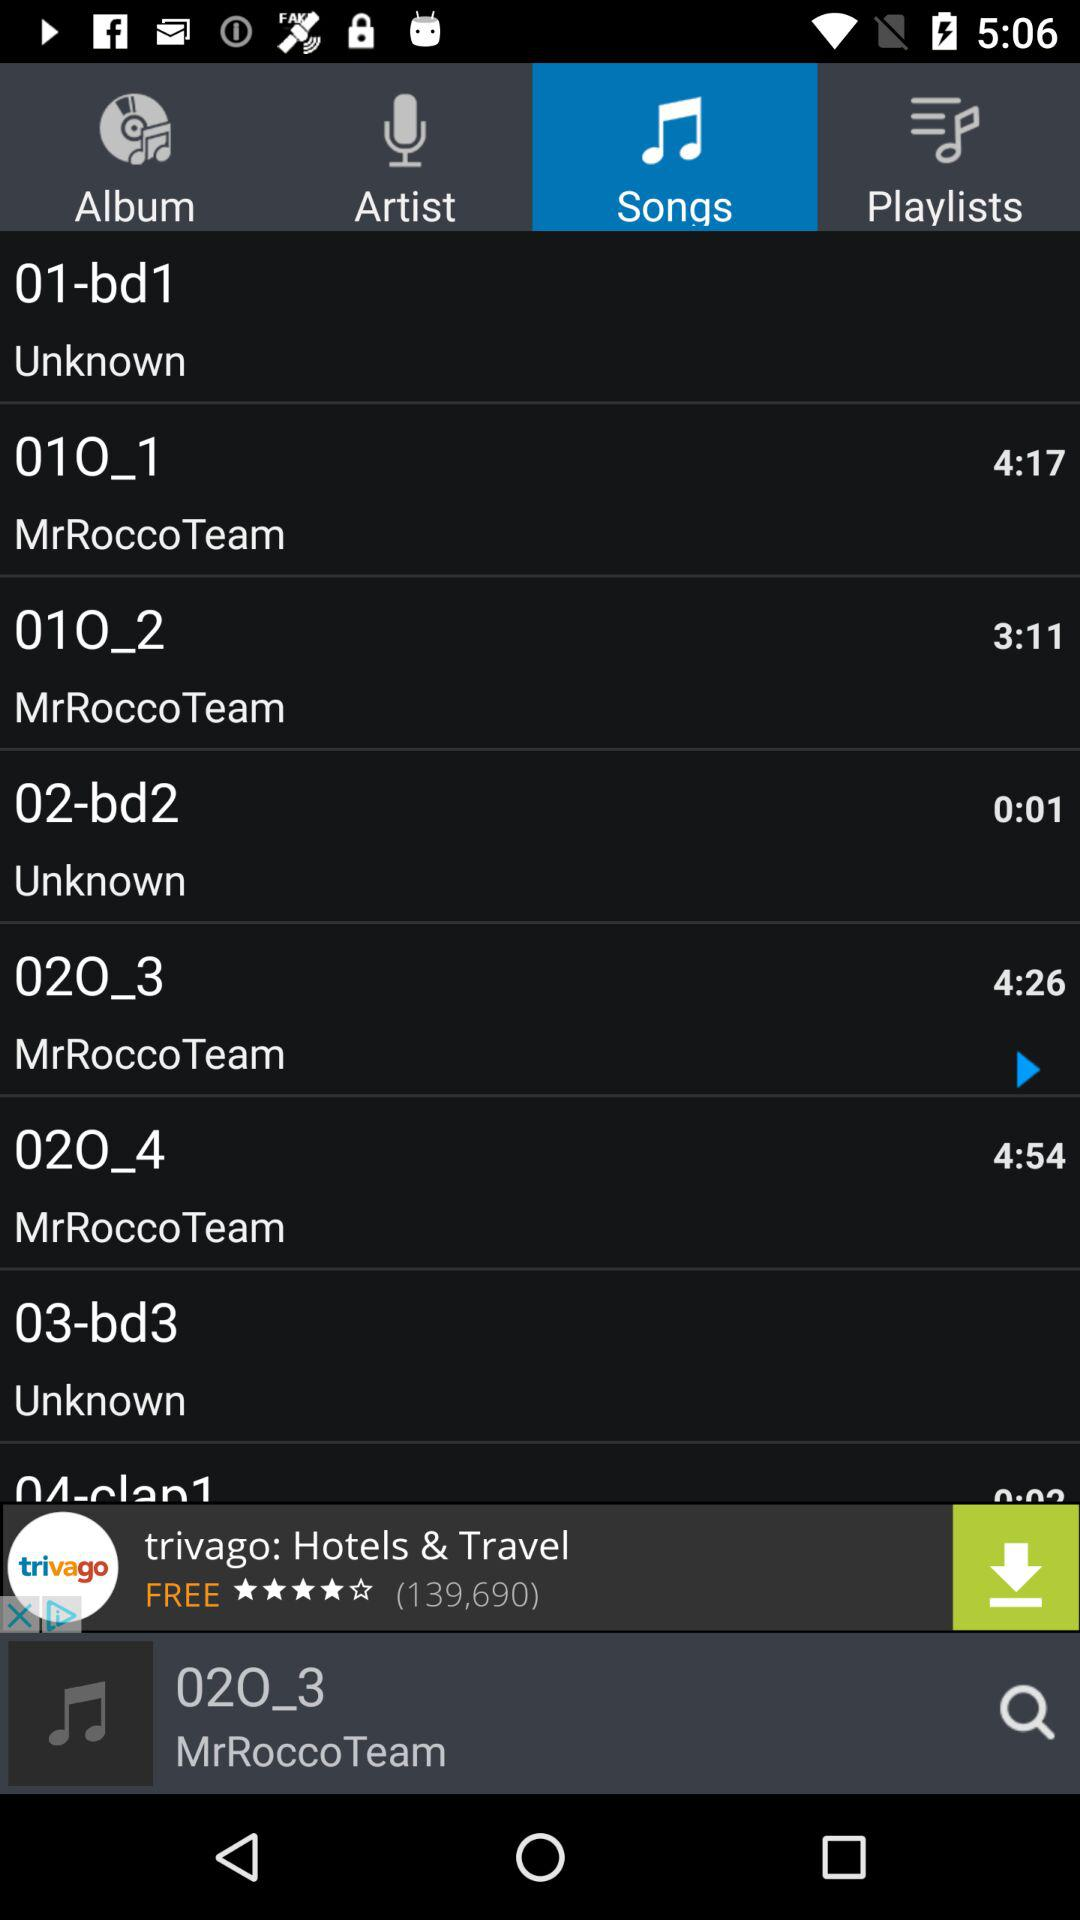Which tab is currently selected? The selected tab is "Songs". 